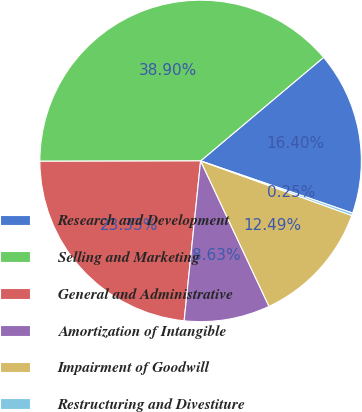<chart> <loc_0><loc_0><loc_500><loc_500><pie_chart><fcel>Research and Development<fcel>Selling and Marketing<fcel>General and Administrative<fcel>Amortization of Intangible<fcel>Impairment of Goodwill<fcel>Restructuring and Divestiture<nl><fcel>16.4%<fcel>38.9%<fcel>23.33%<fcel>8.63%<fcel>12.49%<fcel>0.25%<nl></chart> 